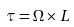Convert formula to latex. <formula><loc_0><loc_0><loc_500><loc_500>\tau = \Omega \times L</formula> 